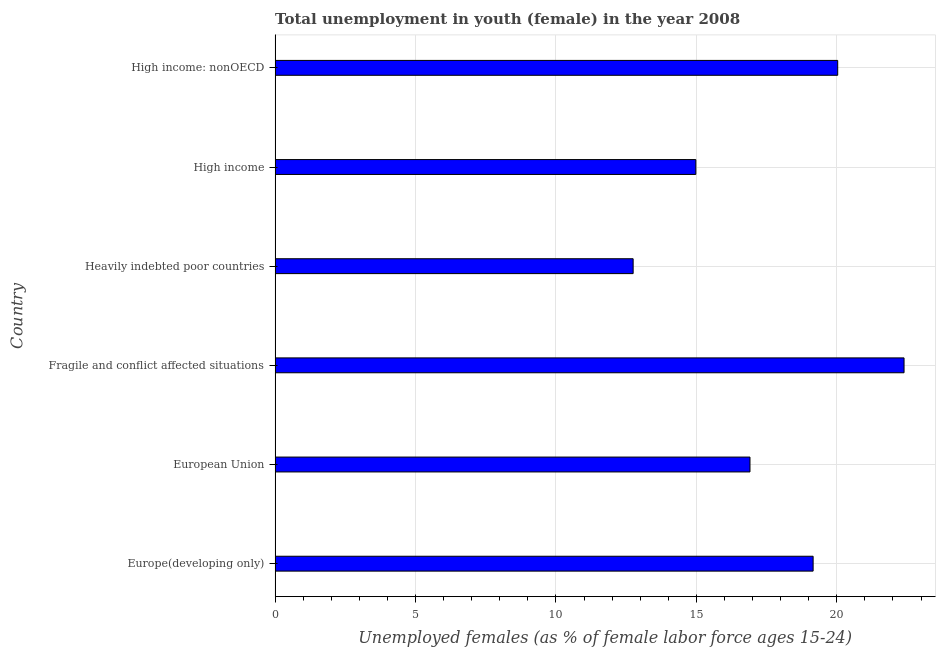Does the graph contain any zero values?
Ensure brevity in your answer.  No. What is the title of the graph?
Offer a terse response. Total unemployment in youth (female) in the year 2008. What is the label or title of the X-axis?
Keep it short and to the point. Unemployed females (as % of female labor force ages 15-24). What is the label or title of the Y-axis?
Provide a short and direct response. Country. What is the unemployed female youth population in Europe(developing only)?
Your answer should be compact. 19.16. Across all countries, what is the maximum unemployed female youth population?
Ensure brevity in your answer.  22.39. Across all countries, what is the minimum unemployed female youth population?
Your answer should be very brief. 12.75. In which country was the unemployed female youth population maximum?
Give a very brief answer. Fragile and conflict affected situations. In which country was the unemployed female youth population minimum?
Offer a very short reply. Heavily indebted poor countries. What is the sum of the unemployed female youth population?
Provide a succinct answer. 106.22. What is the difference between the unemployed female youth population in Heavily indebted poor countries and High income: nonOECD?
Provide a succinct answer. -7.28. What is the average unemployed female youth population per country?
Keep it short and to the point. 17.7. What is the median unemployed female youth population?
Make the answer very short. 18.03. What is the ratio of the unemployed female youth population in European Union to that in Fragile and conflict affected situations?
Make the answer very short. 0.76. Is the unemployed female youth population in European Union less than that in Fragile and conflict affected situations?
Offer a terse response. Yes. What is the difference between the highest and the second highest unemployed female youth population?
Give a very brief answer. 2.36. What is the difference between the highest and the lowest unemployed female youth population?
Ensure brevity in your answer.  9.65. In how many countries, is the unemployed female youth population greater than the average unemployed female youth population taken over all countries?
Your answer should be compact. 3. How many bars are there?
Your answer should be very brief. 6. Are all the bars in the graph horizontal?
Offer a very short reply. Yes. What is the difference between two consecutive major ticks on the X-axis?
Offer a very short reply. 5. Are the values on the major ticks of X-axis written in scientific E-notation?
Provide a short and direct response. No. What is the Unemployed females (as % of female labor force ages 15-24) of Europe(developing only)?
Provide a succinct answer. 19.16. What is the Unemployed females (as % of female labor force ages 15-24) of European Union?
Give a very brief answer. 16.91. What is the Unemployed females (as % of female labor force ages 15-24) of Fragile and conflict affected situations?
Provide a short and direct response. 22.39. What is the Unemployed females (as % of female labor force ages 15-24) in Heavily indebted poor countries?
Provide a succinct answer. 12.75. What is the Unemployed females (as % of female labor force ages 15-24) in High income?
Offer a terse response. 14.98. What is the Unemployed females (as % of female labor force ages 15-24) in High income: nonOECD?
Your response must be concise. 20.03. What is the difference between the Unemployed females (as % of female labor force ages 15-24) in Europe(developing only) and European Union?
Offer a terse response. 2.25. What is the difference between the Unemployed females (as % of female labor force ages 15-24) in Europe(developing only) and Fragile and conflict affected situations?
Keep it short and to the point. -3.24. What is the difference between the Unemployed females (as % of female labor force ages 15-24) in Europe(developing only) and Heavily indebted poor countries?
Offer a terse response. 6.41. What is the difference between the Unemployed females (as % of female labor force ages 15-24) in Europe(developing only) and High income?
Give a very brief answer. 4.18. What is the difference between the Unemployed females (as % of female labor force ages 15-24) in Europe(developing only) and High income: nonOECD?
Offer a terse response. -0.88. What is the difference between the Unemployed females (as % of female labor force ages 15-24) in European Union and Fragile and conflict affected situations?
Provide a succinct answer. -5.49. What is the difference between the Unemployed females (as % of female labor force ages 15-24) in European Union and Heavily indebted poor countries?
Provide a short and direct response. 4.16. What is the difference between the Unemployed females (as % of female labor force ages 15-24) in European Union and High income?
Ensure brevity in your answer.  1.93. What is the difference between the Unemployed females (as % of female labor force ages 15-24) in European Union and High income: nonOECD?
Keep it short and to the point. -3.12. What is the difference between the Unemployed females (as % of female labor force ages 15-24) in Fragile and conflict affected situations and Heavily indebted poor countries?
Make the answer very short. 9.65. What is the difference between the Unemployed females (as % of female labor force ages 15-24) in Fragile and conflict affected situations and High income?
Ensure brevity in your answer.  7.41. What is the difference between the Unemployed females (as % of female labor force ages 15-24) in Fragile and conflict affected situations and High income: nonOECD?
Your answer should be compact. 2.36. What is the difference between the Unemployed females (as % of female labor force ages 15-24) in Heavily indebted poor countries and High income?
Your answer should be very brief. -2.23. What is the difference between the Unemployed females (as % of female labor force ages 15-24) in Heavily indebted poor countries and High income: nonOECD?
Provide a short and direct response. -7.28. What is the difference between the Unemployed females (as % of female labor force ages 15-24) in High income and High income: nonOECD?
Your response must be concise. -5.05. What is the ratio of the Unemployed females (as % of female labor force ages 15-24) in Europe(developing only) to that in European Union?
Provide a short and direct response. 1.13. What is the ratio of the Unemployed females (as % of female labor force ages 15-24) in Europe(developing only) to that in Fragile and conflict affected situations?
Your response must be concise. 0.85. What is the ratio of the Unemployed females (as % of female labor force ages 15-24) in Europe(developing only) to that in Heavily indebted poor countries?
Give a very brief answer. 1.5. What is the ratio of the Unemployed females (as % of female labor force ages 15-24) in Europe(developing only) to that in High income?
Your answer should be very brief. 1.28. What is the ratio of the Unemployed females (as % of female labor force ages 15-24) in Europe(developing only) to that in High income: nonOECD?
Offer a very short reply. 0.96. What is the ratio of the Unemployed females (as % of female labor force ages 15-24) in European Union to that in Fragile and conflict affected situations?
Provide a short and direct response. 0.76. What is the ratio of the Unemployed females (as % of female labor force ages 15-24) in European Union to that in Heavily indebted poor countries?
Keep it short and to the point. 1.33. What is the ratio of the Unemployed females (as % of female labor force ages 15-24) in European Union to that in High income?
Keep it short and to the point. 1.13. What is the ratio of the Unemployed females (as % of female labor force ages 15-24) in European Union to that in High income: nonOECD?
Provide a short and direct response. 0.84. What is the ratio of the Unemployed females (as % of female labor force ages 15-24) in Fragile and conflict affected situations to that in Heavily indebted poor countries?
Your answer should be very brief. 1.76. What is the ratio of the Unemployed females (as % of female labor force ages 15-24) in Fragile and conflict affected situations to that in High income?
Keep it short and to the point. 1.5. What is the ratio of the Unemployed females (as % of female labor force ages 15-24) in Fragile and conflict affected situations to that in High income: nonOECD?
Give a very brief answer. 1.12. What is the ratio of the Unemployed females (as % of female labor force ages 15-24) in Heavily indebted poor countries to that in High income?
Offer a very short reply. 0.85. What is the ratio of the Unemployed females (as % of female labor force ages 15-24) in Heavily indebted poor countries to that in High income: nonOECD?
Give a very brief answer. 0.64. What is the ratio of the Unemployed females (as % of female labor force ages 15-24) in High income to that in High income: nonOECD?
Make the answer very short. 0.75. 